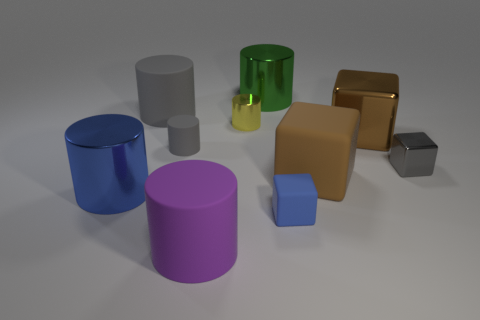There is a large metallic object that is the same color as the tiny matte cube; what is its shape?
Give a very brief answer. Cylinder. What is the material of the cylinder in front of the small cube in front of the metallic object in front of the gray metal object?
Ensure brevity in your answer.  Rubber. How many rubber things are green objects or cylinders?
Provide a short and direct response. 3. Do the large matte block and the small shiny block have the same color?
Keep it short and to the point. No. Is there any other thing that is the same material as the large purple cylinder?
Give a very brief answer. Yes. How many objects are either large cyan metallic blocks or metallic objects in front of the green thing?
Make the answer very short. 4. Does the green cylinder that is behind the brown metallic block have the same size as the large blue metal cylinder?
Your answer should be very brief. Yes. What number of other things are the same shape as the big brown metallic thing?
Keep it short and to the point. 3. How many yellow objects are tiny rubber objects or big objects?
Your answer should be compact. 0. There is a big metal thing that is on the left side of the tiny yellow metallic thing; is it the same color as the tiny rubber cube?
Offer a terse response. Yes. 